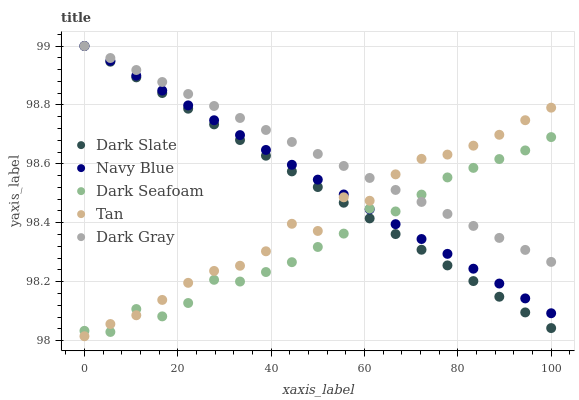Does Dark Seafoam have the minimum area under the curve?
Answer yes or no. Yes. Does Dark Gray have the maximum area under the curve?
Answer yes or no. Yes. Does Dark Slate have the minimum area under the curve?
Answer yes or no. No. Does Dark Slate have the maximum area under the curve?
Answer yes or no. No. Is Navy Blue the smoothest?
Answer yes or no. Yes. Is Tan the roughest?
Answer yes or no. Yes. Is Dark Slate the smoothest?
Answer yes or no. No. Is Dark Slate the roughest?
Answer yes or no. No. Does Tan have the lowest value?
Answer yes or no. Yes. Does Dark Slate have the lowest value?
Answer yes or no. No. Does Navy Blue have the highest value?
Answer yes or no. Yes. Does Dark Seafoam have the highest value?
Answer yes or no. No. Does Dark Gray intersect Navy Blue?
Answer yes or no. Yes. Is Dark Gray less than Navy Blue?
Answer yes or no. No. Is Dark Gray greater than Navy Blue?
Answer yes or no. No. 